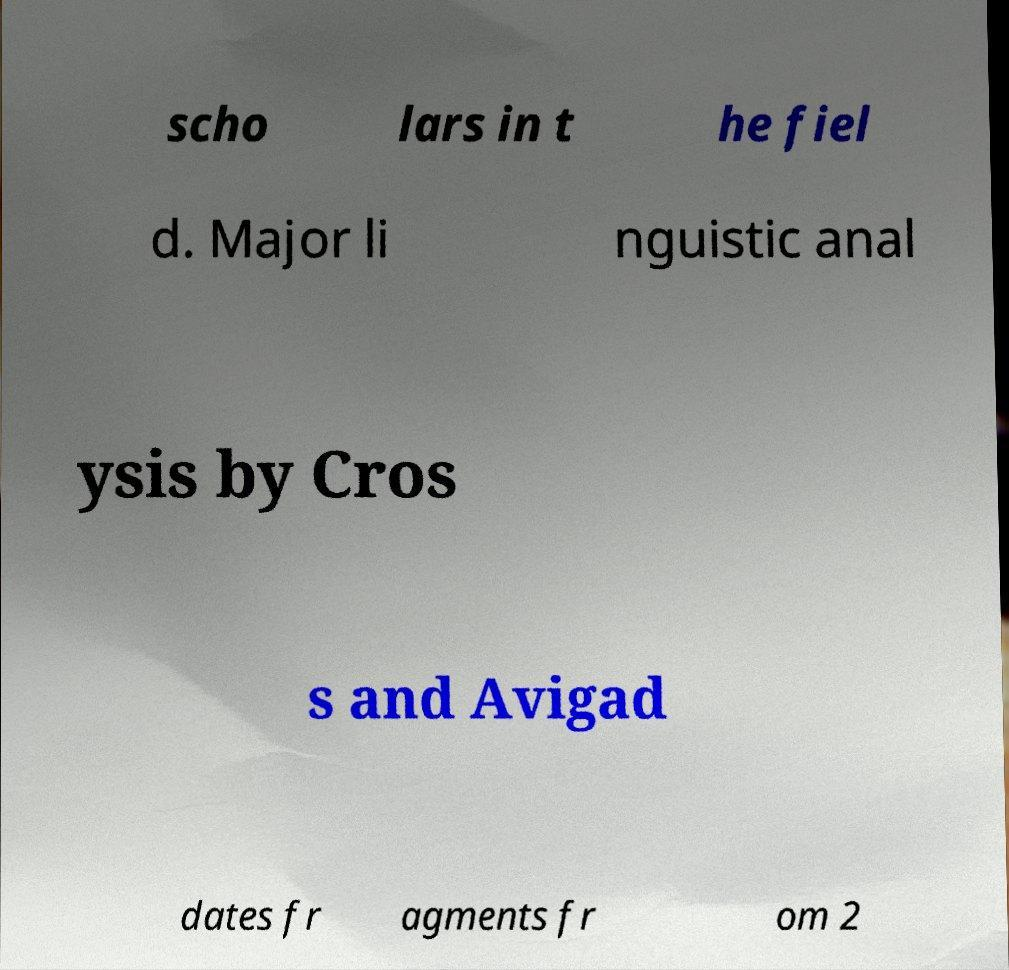What messages or text are displayed in this image? I need them in a readable, typed format. scho lars in t he fiel d. Major li nguistic anal ysis by Cros s and Avigad dates fr agments fr om 2 